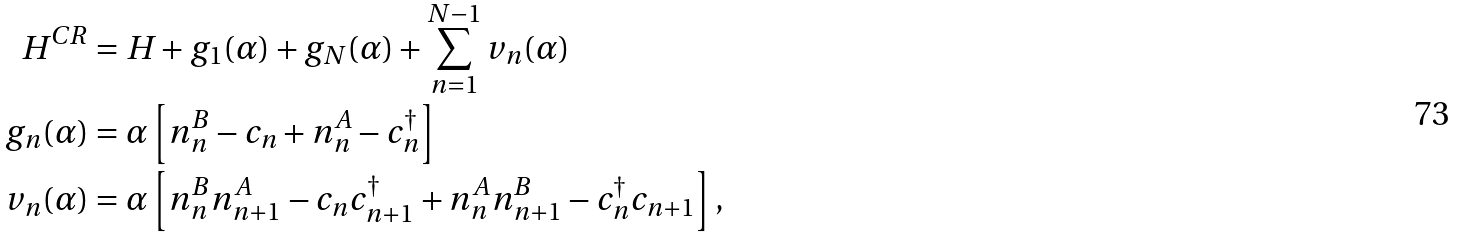Convert formula to latex. <formula><loc_0><loc_0><loc_500><loc_500>H ^ { C R } & = H + g _ { 1 } ( \alpha ) + g _ { N } ( \alpha ) + \sum _ { n = 1 } ^ { N - 1 } v _ { n } ( \alpha ) \\ g _ { n } ( \alpha ) & = \alpha \left [ n _ { n } ^ { B } - c _ { n } + n _ { n } ^ { A } - c _ { n } ^ { \dagger } \right ] \\ v _ { n } ( \alpha ) & = \alpha \left [ n _ { n } ^ { B } n _ { n + 1 } ^ { A } - c _ { n } c ^ { \dagger } _ { n + 1 } + n _ { n } ^ { A } n _ { n + 1 } ^ { B } - c _ { n } ^ { \dagger } c _ { n + 1 } \right ] ,</formula> 